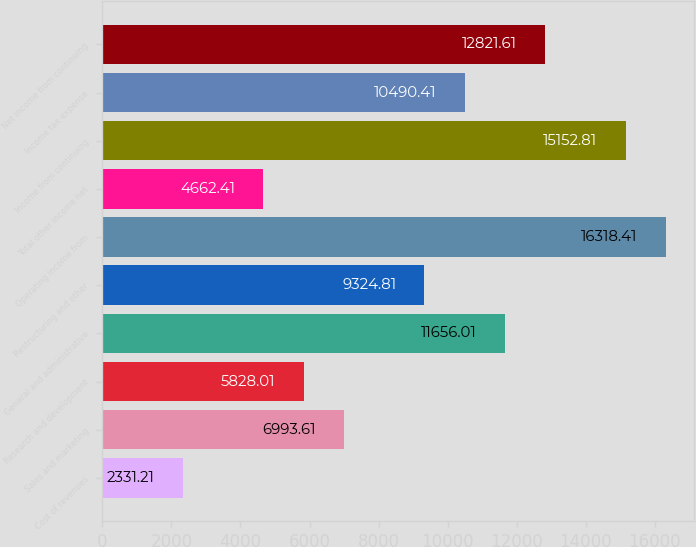Convert chart to OTSL. <chart><loc_0><loc_0><loc_500><loc_500><bar_chart><fcel>Cost of revenues<fcel>Sales and marketing<fcel>Research and development<fcel>General and administrative<fcel>Restructuring and other<fcel>Operating income from<fcel>Total other income net<fcel>Income from continuing<fcel>Income tax expense<fcel>Net income from continuing<nl><fcel>2331.21<fcel>6993.61<fcel>5828.01<fcel>11656<fcel>9324.81<fcel>16318.4<fcel>4662.41<fcel>15152.8<fcel>10490.4<fcel>12821.6<nl></chart> 